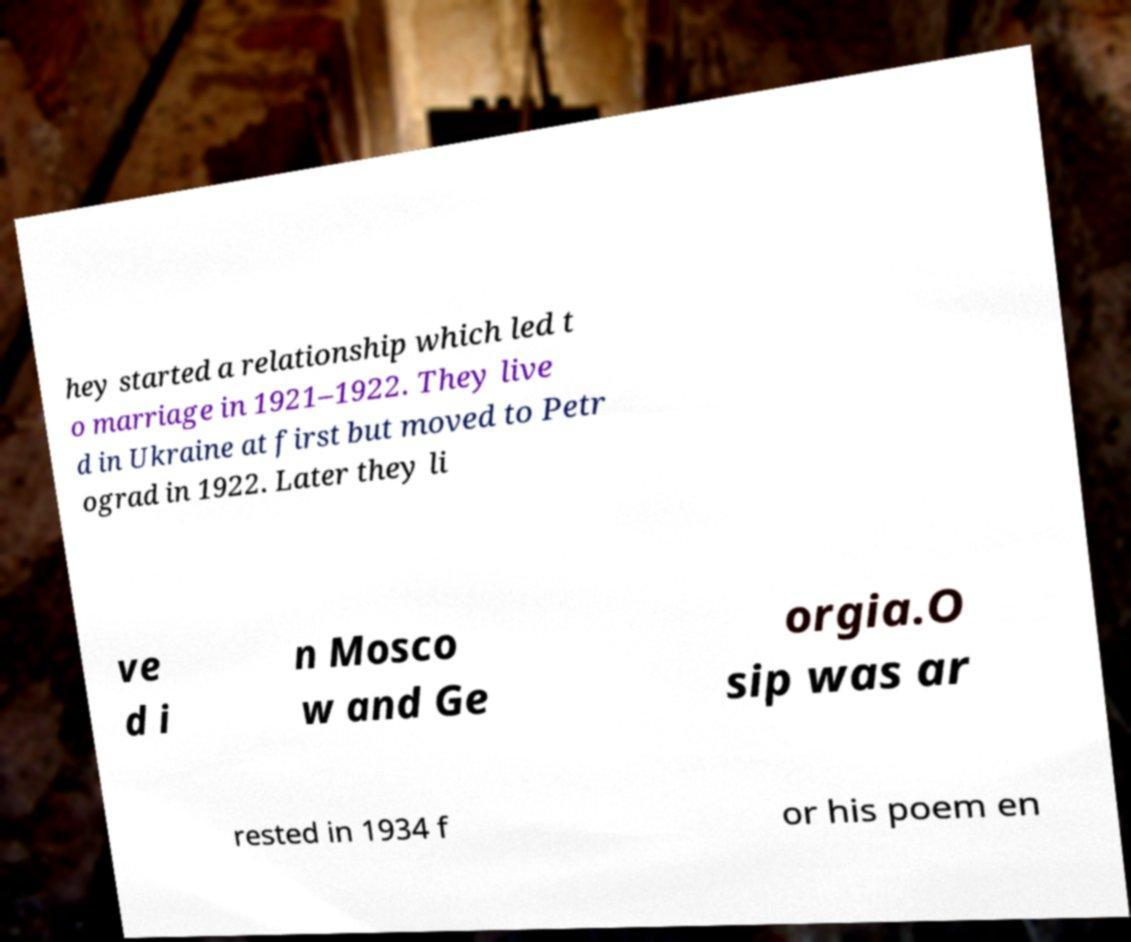Could you extract and type out the text from this image? hey started a relationship which led t o marriage in 1921–1922. They live d in Ukraine at first but moved to Petr ograd in 1922. Later they li ve d i n Mosco w and Ge orgia.O sip was ar rested in 1934 f or his poem en 